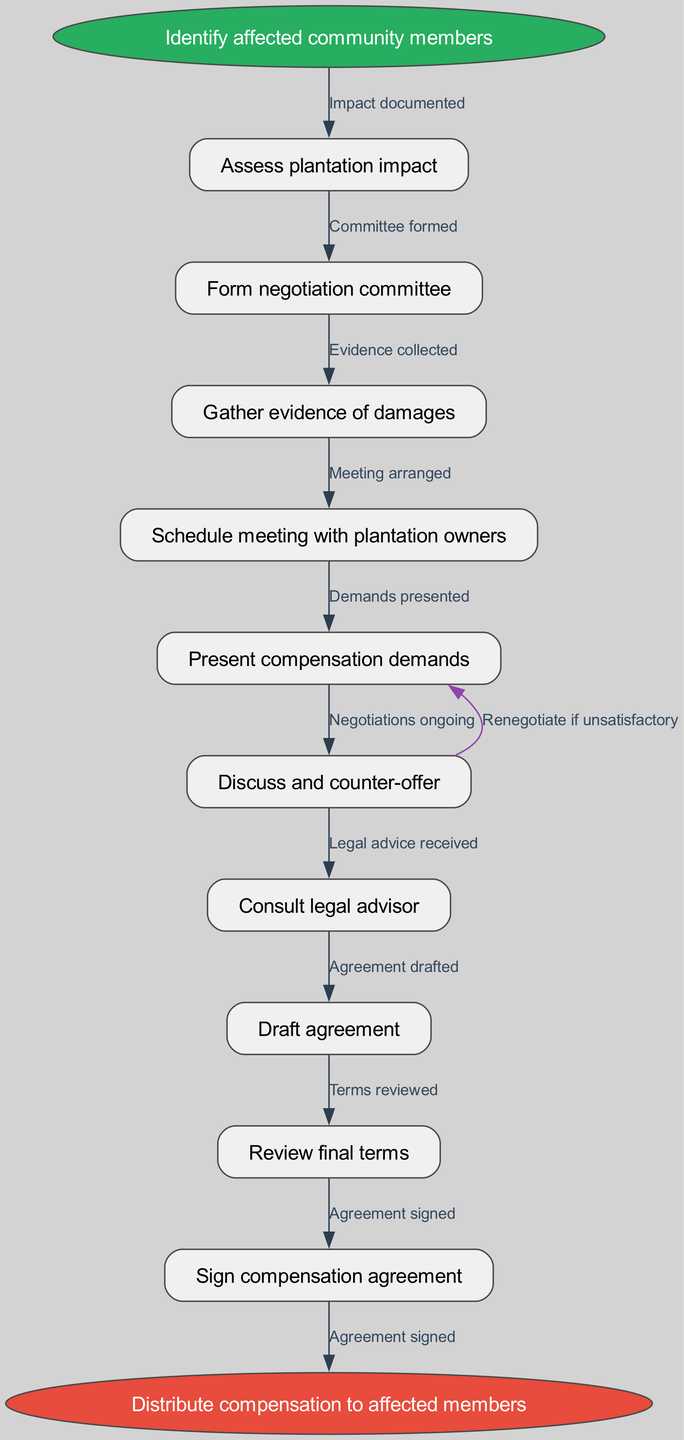What is the first step in the workflow? The diagram starts with the node that states "Identify affected community members" as the first step. This is visually represented as the starting point of the flowchart.
Answer: Identify affected community members How many nodes are present in the diagram? The diagram includes a total of 11 nodes: one start node, 9 intermediate nodes, and one end node. By counting each of them, we find the total.
Answer: 11 What action follows after assessing plantation impact? After "Assess plantation impact," the next node in the flowchart is "Form negotiation committee." This follows directly after the impact assessment based on the flow lines connecting the nodes.
Answer: Form negotiation committee Which node comes right before the final distribution of compensation? The node right before "Distribute compensation to affected members" is "Sign compensation agreement." This step is the last before the end node, as shown in the diagram's flow.
Answer: Sign compensation agreement What happens if the compensation agreement is unsatisfactory? If the compensation agreement is unsatisfactory, the workflow indicates to "Renegotiate if unsatisfactory," which is shown as a looping arrow going back to "Present compensation demands." This represents the renegotiation process.
Answer: Renegotiate if unsatisfactory How does the negotiation committee form in the workflow? The negotiation committee forms after assessing the plantation impact, as indicated by the directed edge from the "Assess plantation impact" node to the "Form negotiation committee" node in the flowchart.
Answer: Committee formed What is the final outcome of the workflow in the diagram? The final outcome indicated in the flowchart is "Distribute compensation to affected members." This is the endpoint of the negotiated process.
Answer: Distribute compensation to affected members What document is drafted after legal advice is received? The document that is drafted after legal advice is received is the "Draft agreement," which is connected sequentially in the workflow following the node for receiving legal advice.
Answer: Draft agreement What is the color of the start node in the diagram? The start node is colored green, specifically using the fill color '#27ae60' as defined in the diagram's attributes. This color visually emphasizes the initial step.
Answer: Green 